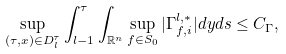Convert formula to latex. <formula><loc_0><loc_0><loc_500><loc_500>\sup _ { ( \tau , x ) \in D ^ { \tau } _ { l } } \int _ { l - 1 } ^ { \tau } \int _ { { \mathbb { R } } ^ { n } } \sup _ { f \in S _ { 0 } } | \Gamma ^ { l , * } _ { f , i } | d y d s \leq C _ { \Gamma } ,</formula> 